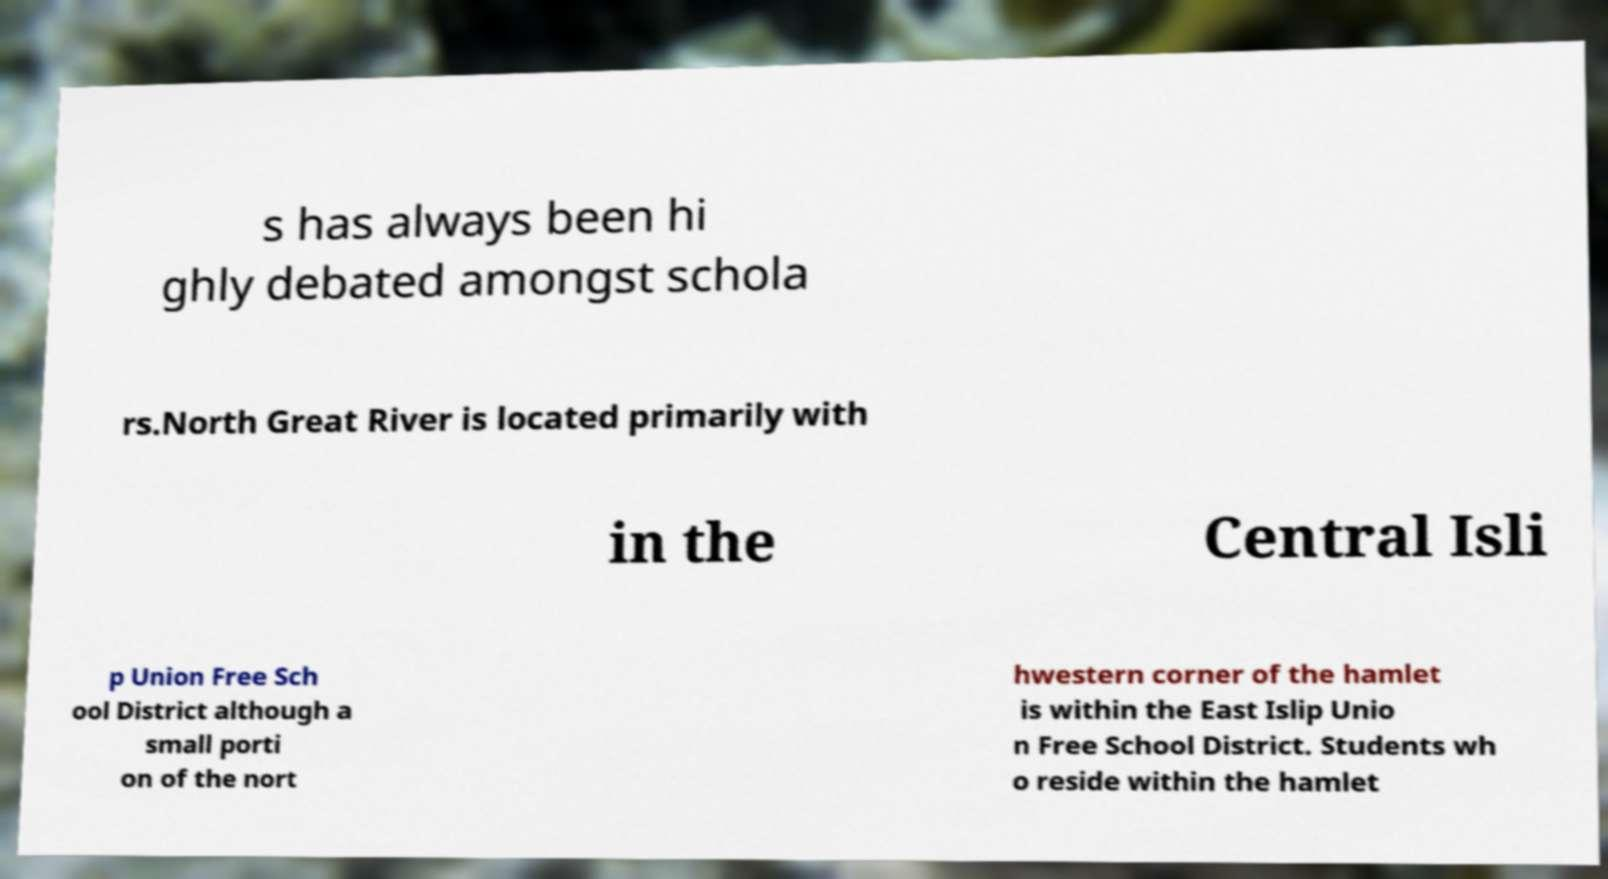I need the written content from this picture converted into text. Can you do that? s has always been hi ghly debated amongst schola rs.North Great River is located primarily with in the Central Isli p Union Free Sch ool District although a small porti on of the nort hwestern corner of the hamlet is within the East Islip Unio n Free School District. Students wh o reside within the hamlet 